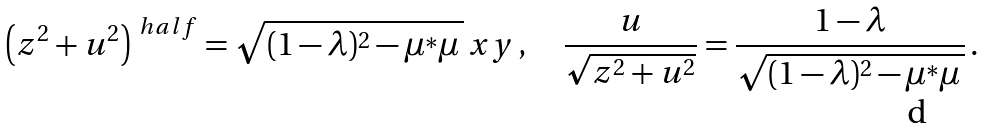<formula> <loc_0><loc_0><loc_500><loc_500>\left ( z ^ { 2 } + u ^ { 2 } \right ) ^ { \ h a l f } = \sqrt { ( 1 - \lambda ) ^ { 2 } - \mu ^ { * } \mu \, } \, x y \, , \quad \frac { u } { \sqrt { z ^ { 2 } + u ^ { 2 } } } = \frac { 1 - \lambda } { \sqrt { ( 1 - \lambda ) ^ { 2 } - \mu ^ { * } \mu \, } } \, .</formula> 